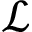<formula> <loc_0><loc_0><loc_500><loc_500>\mathcal { L }</formula> 